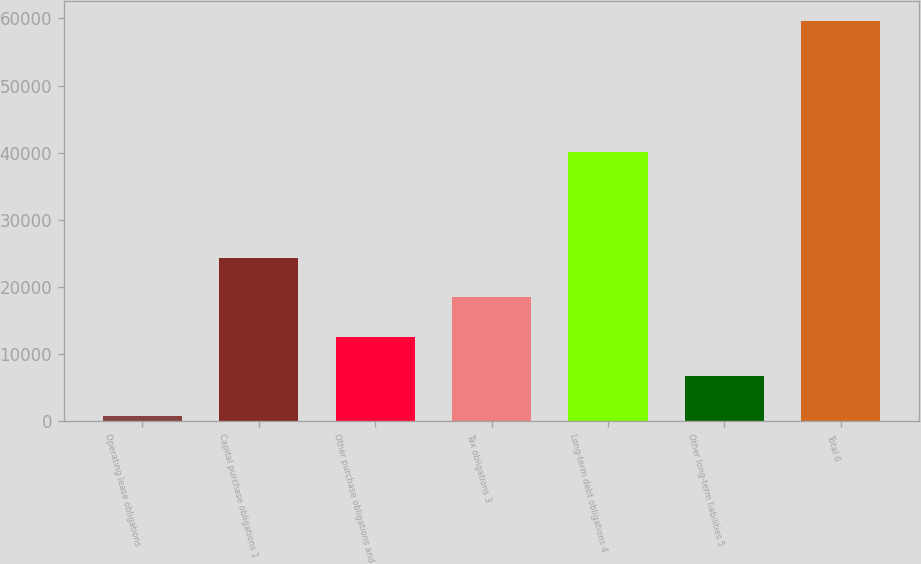Convert chart. <chart><loc_0><loc_0><loc_500><loc_500><bar_chart><fcel>Operating lease obligations<fcel>Capital purchase obligations 1<fcel>Other purchase obligations and<fcel>Tax obligations 3<fcel>Long-term debt obligations 4<fcel>Other long-term liabilities 5<fcel>Total 6<nl><fcel>835<fcel>24364.2<fcel>12599.6<fcel>18481.9<fcel>40187<fcel>6717.3<fcel>59658<nl></chart> 